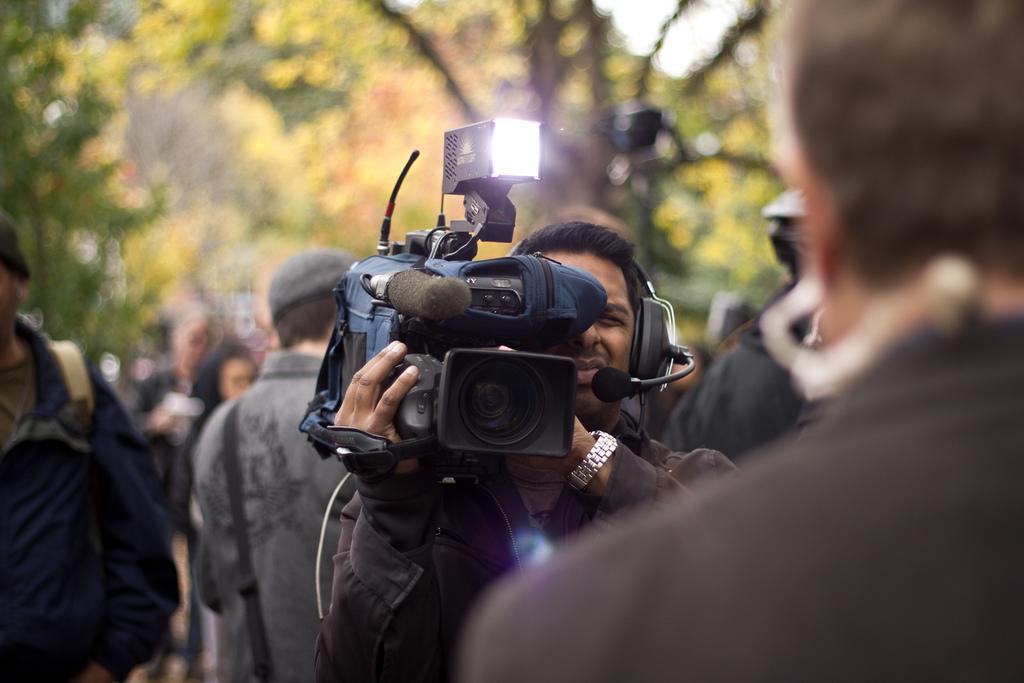Can you describe this image briefly? In the middle a man is recording video around him there are many. There are trees in the background. 